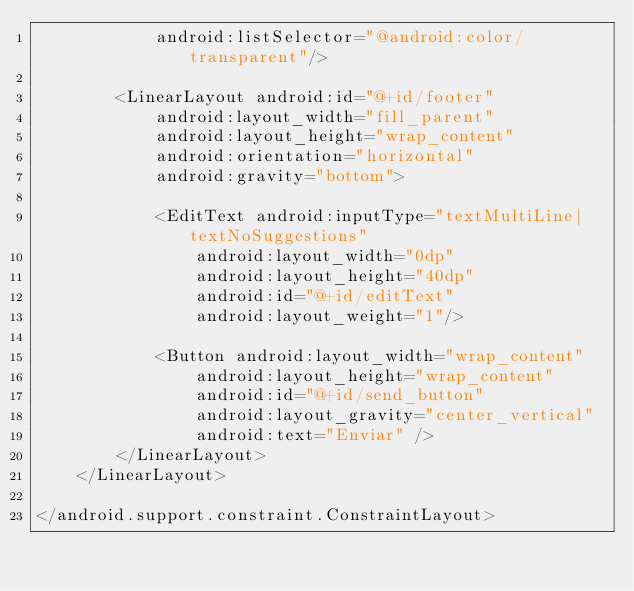<code> <loc_0><loc_0><loc_500><loc_500><_XML_>            android:listSelector="@android:color/transparent"/>

        <LinearLayout android:id="@+id/footer"
            android:layout_width="fill_parent"
            android:layout_height="wrap_content"
            android:orientation="horizontal"
            android:gravity="bottom">

            <EditText android:inputType="textMultiLine|textNoSuggestions"
                android:layout_width="0dp"
                android:layout_height="40dp"
                android:id="@+id/editText"
                android:layout_weight="1"/>

            <Button android:layout_width="wrap_content"
                android:layout_height="wrap_content"
                android:id="@+id/send_button"
                android:layout_gravity="center_vertical"
                android:text="Enviar" />
        </LinearLayout>
    </LinearLayout>

</android.support.constraint.ConstraintLayout>
</code> 